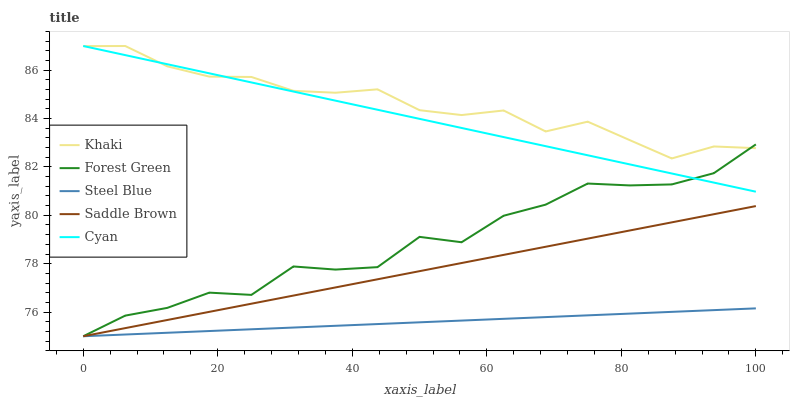Does Forest Green have the minimum area under the curve?
Answer yes or no. No. Does Forest Green have the maximum area under the curve?
Answer yes or no. No. Is Khaki the smoothest?
Answer yes or no. No. Is Khaki the roughest?
Answer yes or no. No. Does Khaki have the lowest value?
Answer yes or no. No. Does Forest Green have the highest value?
Answer yes or no. No. Is Saddle Brown less than Khaki?
Answer yes or no. Yes. Is Cyan greater than Saddle Brown?
Answer yes or no. Yes. Does Saddle Brown intersect Khaki?
Answer yes or no. No. 